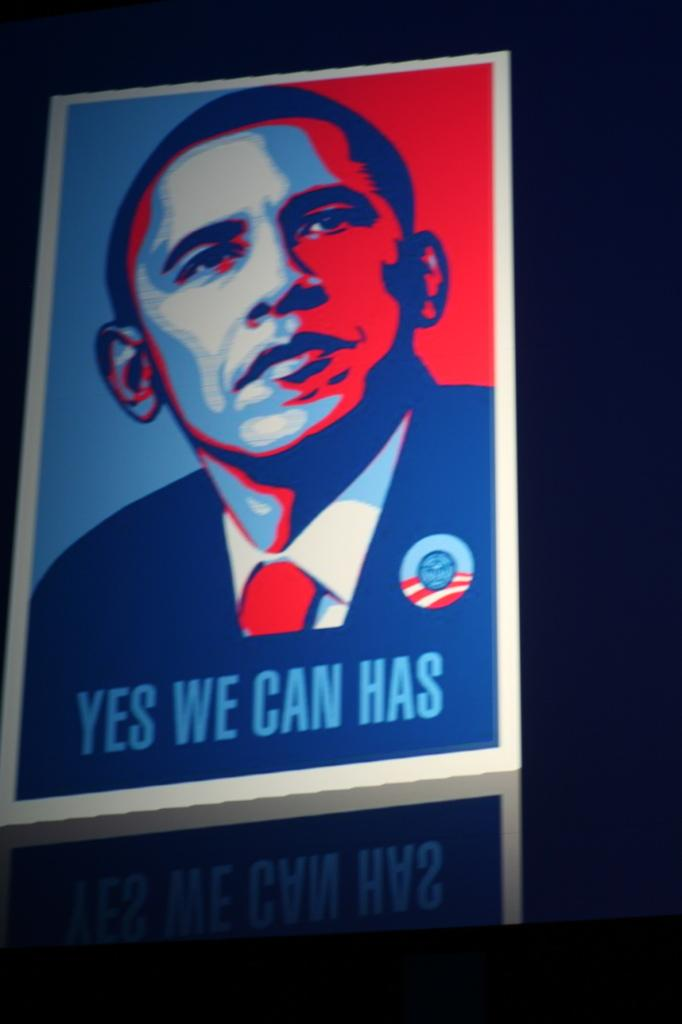<image>
Write a terse but informative summary of the picture. Presidential campaign photo with YES WE CAN HAS in blue letters 